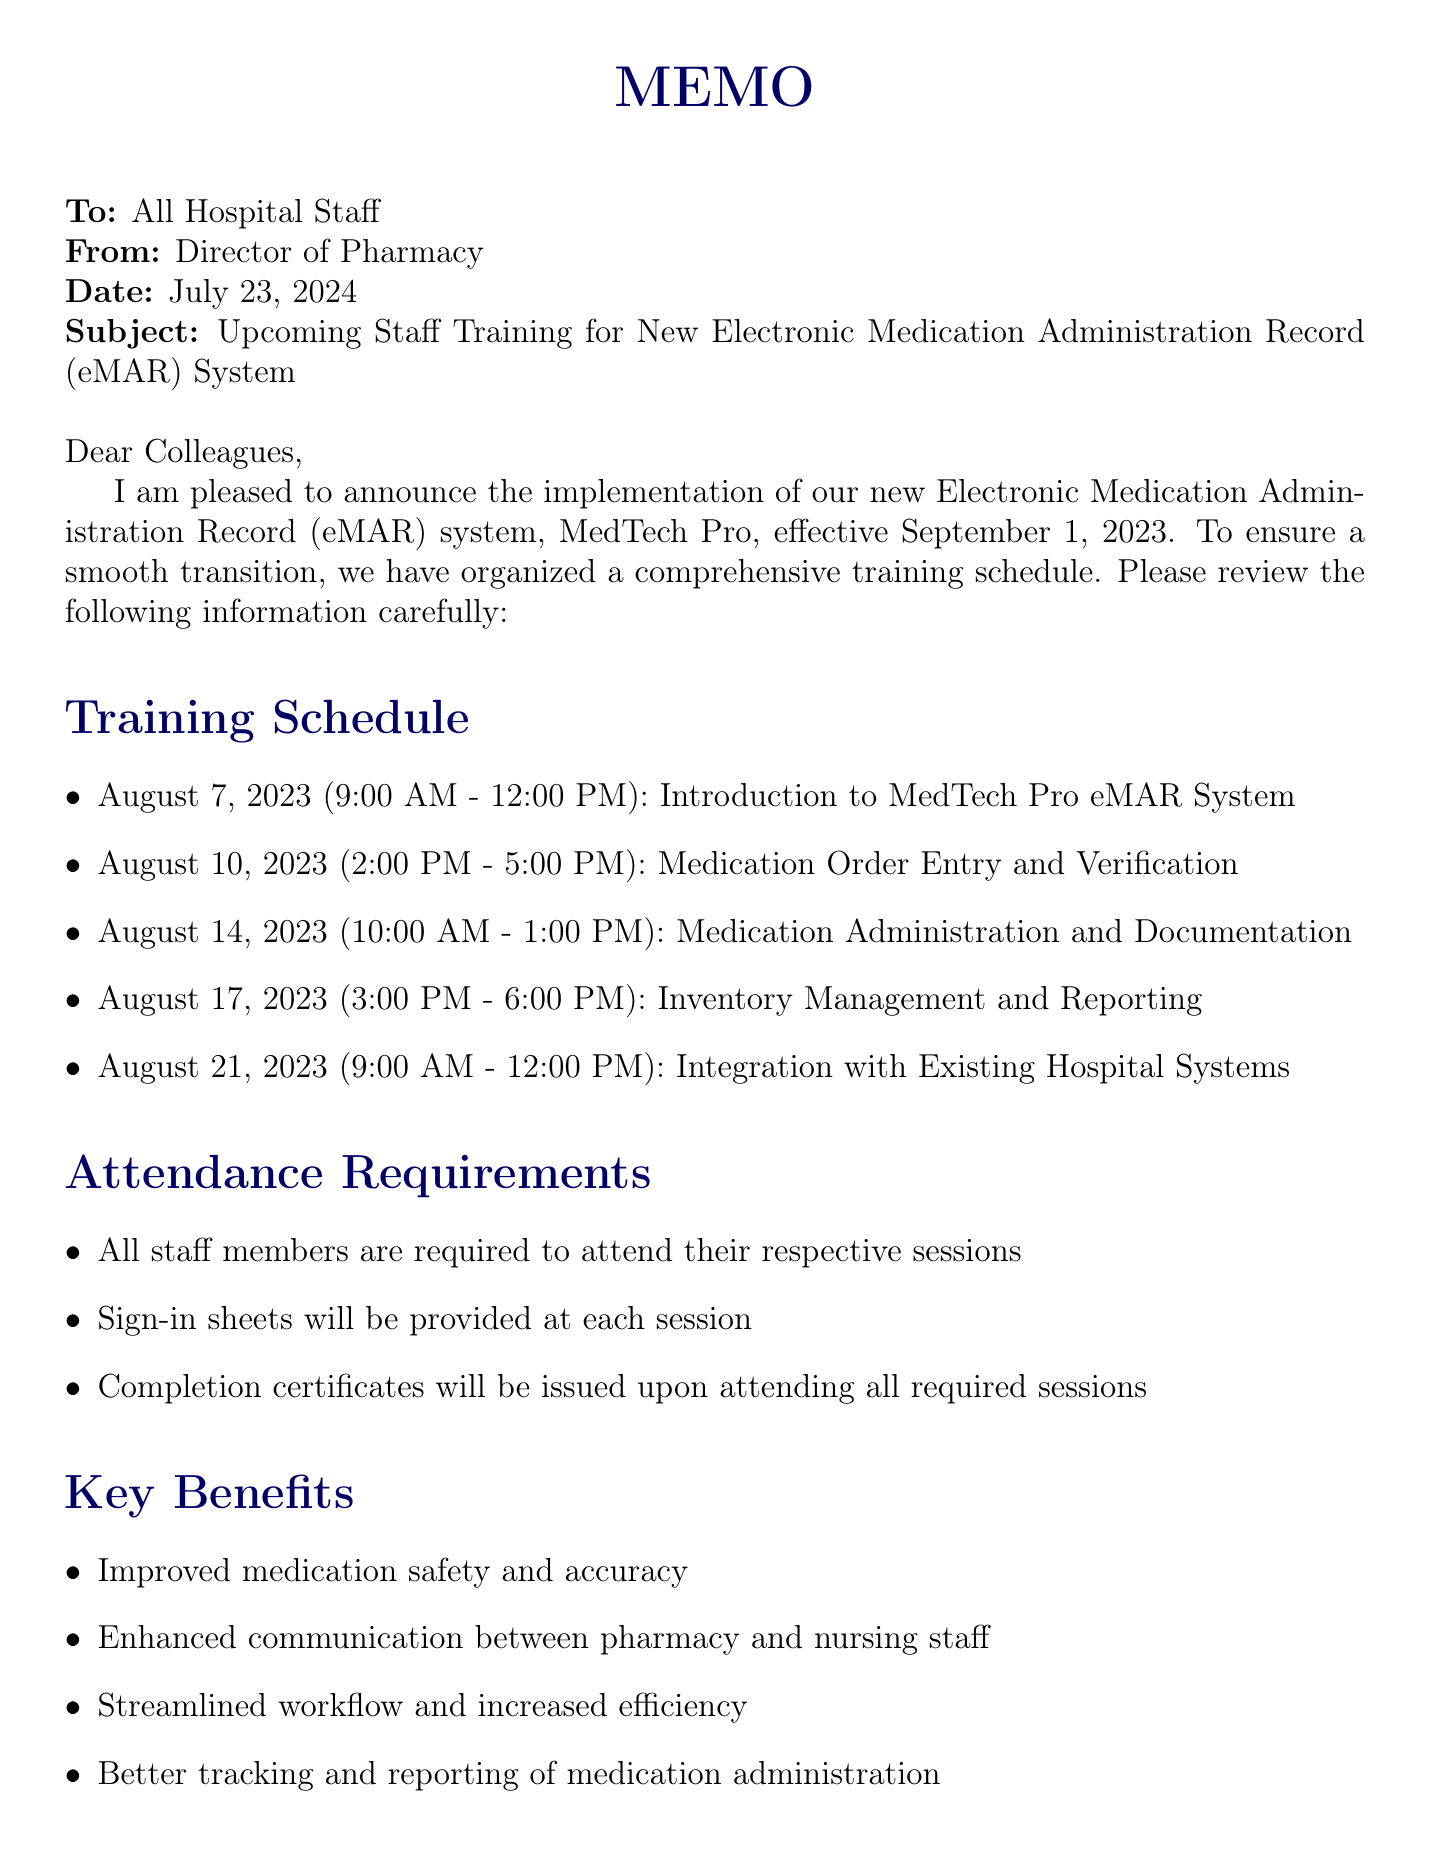What is the name of the eMAR system? The eMAR system in the document is referred to as MedTech Pro.
Answer: MedTech Pro When does the implementation of the new eMAR system take place? The document states the implementation date is September 1, 2023.
Answer: September 1, 2023 Who are required to attend the training session on August 10, 2023? The attendees for that session include pharmacists and pharmacy technicians.
Answer: Pharmacists and pharmacy technicians How many training sessions are listed in the schedule? There are a total of five training sessions mentioned in the document.
Answer: Five What is the purpose of the sign-in sheets at each session? Sign-in sheets will be provided at each session to track attendance for completion certificates.
Answer: Track attendance What are the benefits of the new eMAR system mentioned in the memo? The document outlines benefits such as improved medication safety and accuracy, enhanced communication, streamlined workflow, and better tracking of medication administration.
Answer: Improved medication safety and accuracy, enhanced communication, streamlined workflow, and better tracking of medication administration What should staff bring for system access setup? According to the document, staff should bring their hospital ID for system access setup.
Answer: Hospital ID Who can staff contact for questions regarding the training sessions? The document specifies that staff should direct any questions or concerns to the Pharmacy Director's office.
Answer: Pharmacy Director's office 